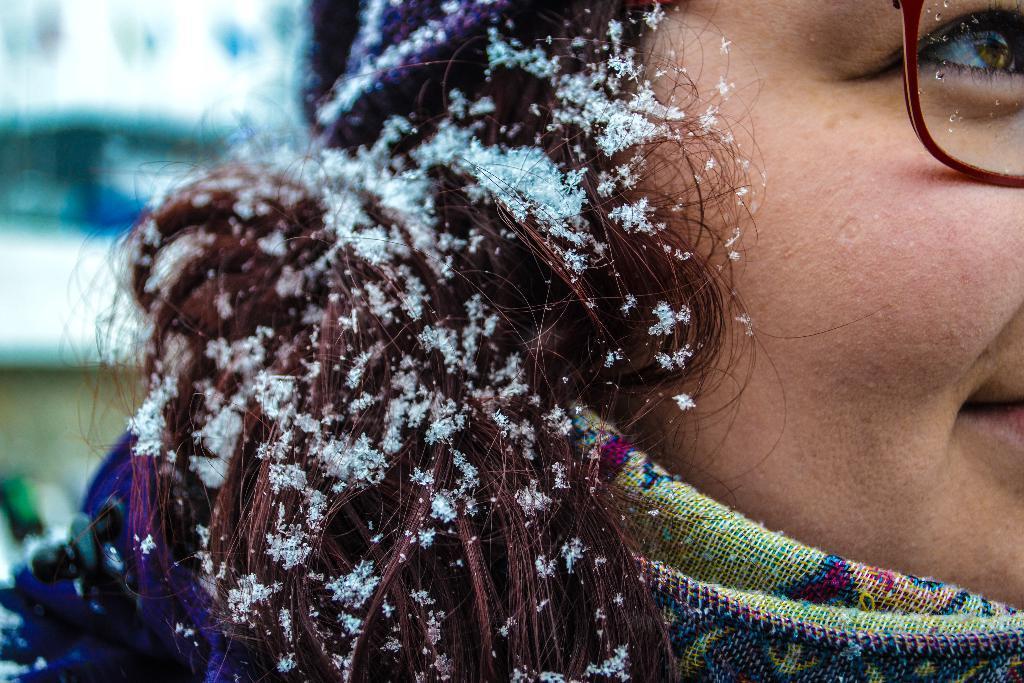How would you summarize this image in a sentence or two? In this image I can see a woman in the front and I can see she is wearing specs. I can also see snow on her hair and I can see this image is little bit blurry in the background. 